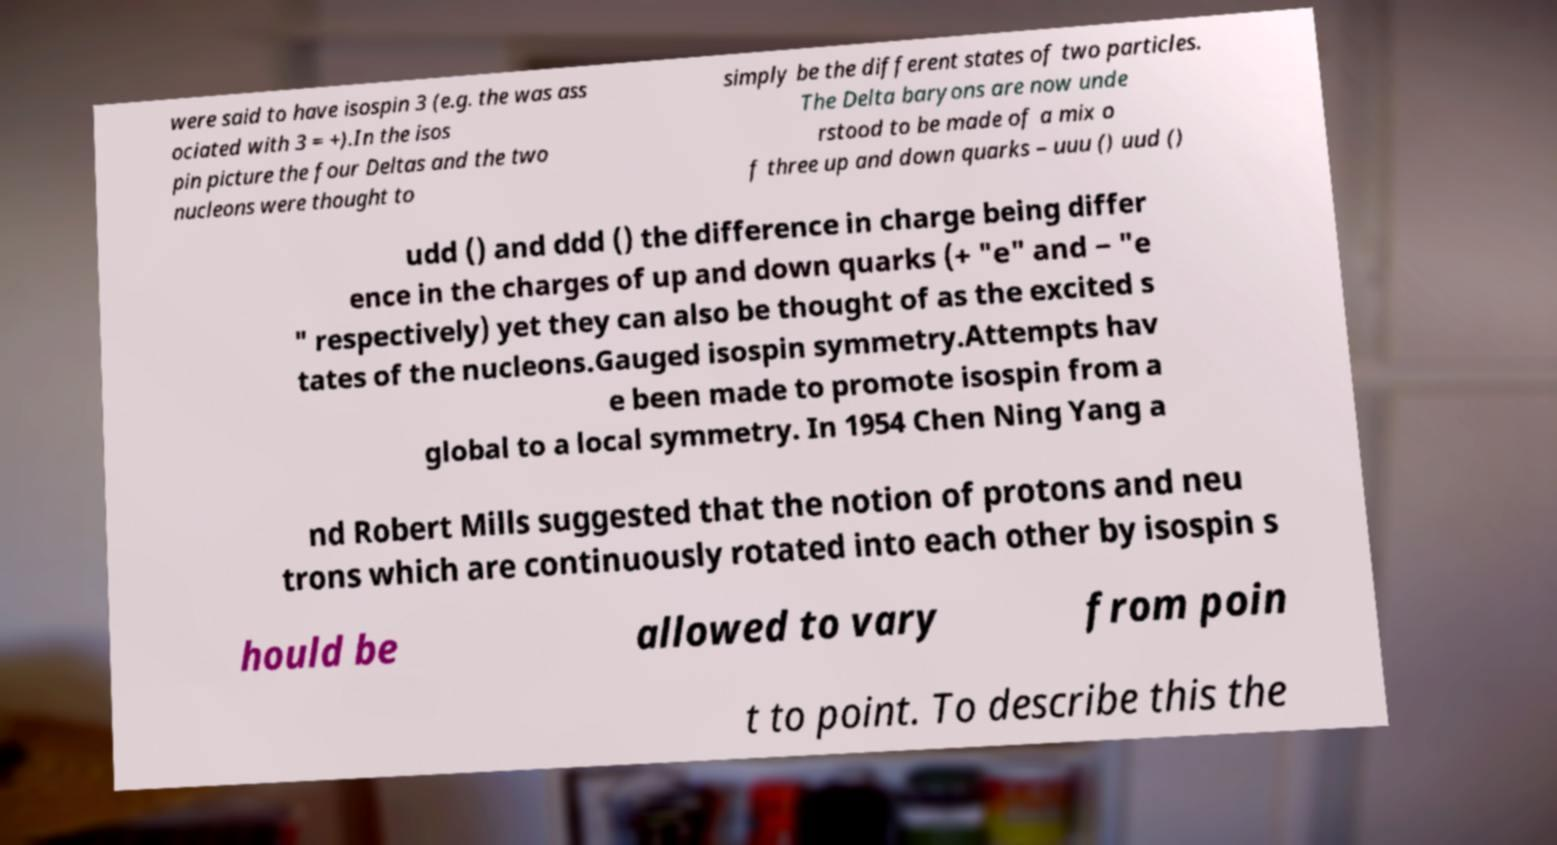Could you extract and type out the text from this image? were said to have isospin 3 (e.g. the was ass ociated with 3 = +).In the isos pin picture the four Deltas and the two nucleons were thought to simply be the different states of two particles. The Delta baryons are now unde rstood to be made of a mix o f three up and down quarks – uuu () uud () udd () and ddd () the difference in charge being differ ence in the charges of up and down quarks (+ "e" and − "e " respectively) yet they can also be thought of as the excited s tates of the nucleons.Gauged isospin symmetry.Attempts hav e been made to promote isospin from a global to a local symmetry. In 1954 Chen Ning Yang a nd Robert Mills suggested that the notion of protons and neu trons which are continuously rotated into each other by isospin s hould be allowed to vary from poin t to point. To describe this the 